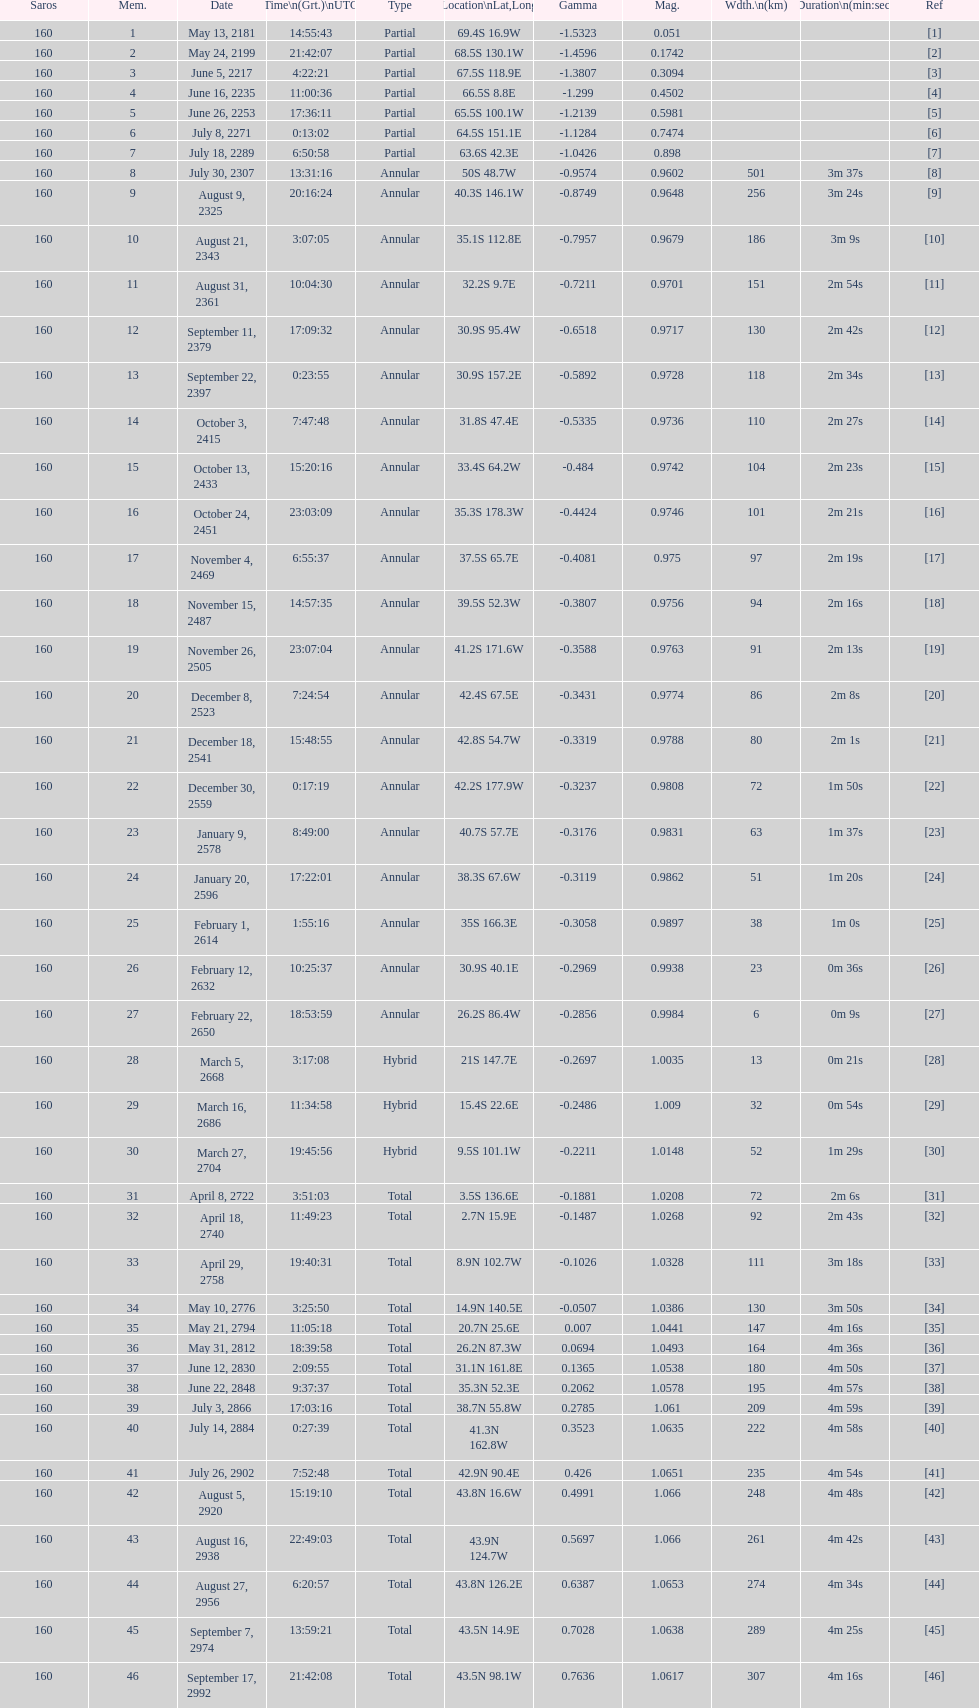Name a member number with a latitude above 60 s. 1. 